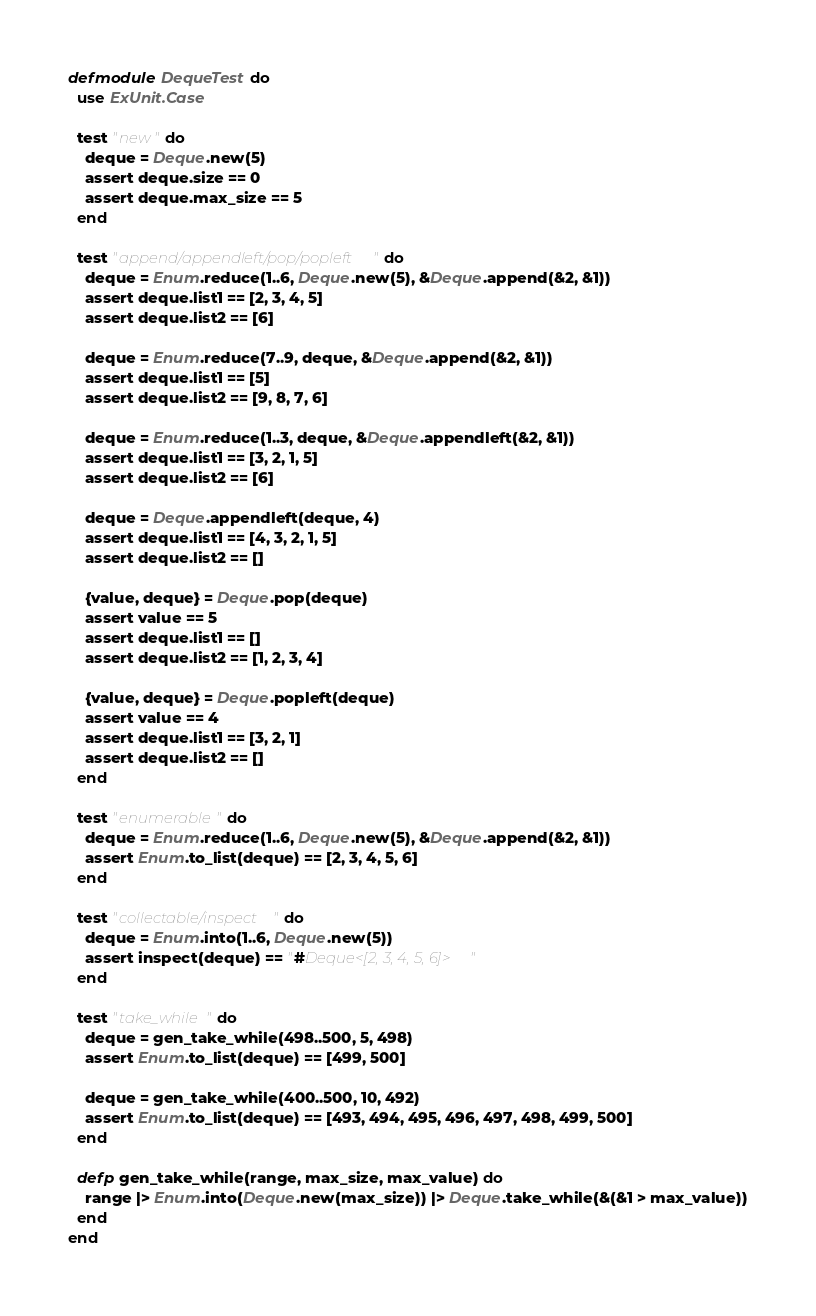Convert code to text. <code><loc_0><loc_0><loc_500><loc_500><_Elixir_>defmodule DequeTest do
  use ExUnit.Case

  test "new" do
    deque = Deque.new(5)
    assert deque.size == 0
    assert deque.max_size == 5
  end

  test "append/appendleft/pop/popleft" do
    deque = Enum.reduce(1..6, Deque.new(5), &Deque.append(&2, &1))
    assert deque.list1 == [2, 3, 4, 5]
    assert deque.list2 == [6]

    deque = Enum.reduce(7..9, deque, &Deque.append(&2, &1))
    assert deque.list1 == [5]
    assert deque.list2 == [9, 8, 7, 6]

    deque = Enum.reduce(1..3, deque, &Deque.appendleft(&2, &1))
    assert deque.list1 == [3, 2, 1, 5]
    assert deque.list2 == [6]

    deque = Deque.appendleft(deque, 4)
    assert deque.list1 == [4, 3, 2, 1, 5]
    assert deque.list2 == []

    {value, deque} = Deque.pop(deque)
    assert value == 5
    assert deque.list1 == []
    assert deque.list2 == [1, 2, 3, 4]

    {value, deque} = Deque.popleft(deque)
    assert value == 4
    assert deque.list1 == [3, 2, 1]
    assert deque.list2 == []
  end

  test "enumerable" do
    deque = Enum.reduce(1..6, Deque.new(5), &Deque.append(&2, &1))
    assert Enum.to_list(deque) == [2, 3, 4, 5, 6]
  end

  test "collectable/inspect" do
    deque = Enum.into(1..6, Deque.new(5))
    assert inspect(deque) == "#Deque<[2, 3, 4, 5, 6]>"
  end

  test "take_while" do
    deque = gen_take_while(498..500, 5, 498)
    assert Enum.to_list(deque) == [499, 500]

    deque = gen_take_while(400..500, 10, 492)
    assert Enum.to_list(deque) == [493, 494, 495, 496, 497, 498, 499, 500]
  end

  defp gen_take_while(range, max_size, max_value) do
    range |> Enum.into(Deque.new(max_size)) |> Deque.take_while(&(&1 > max_value))
  end
end
</code> 